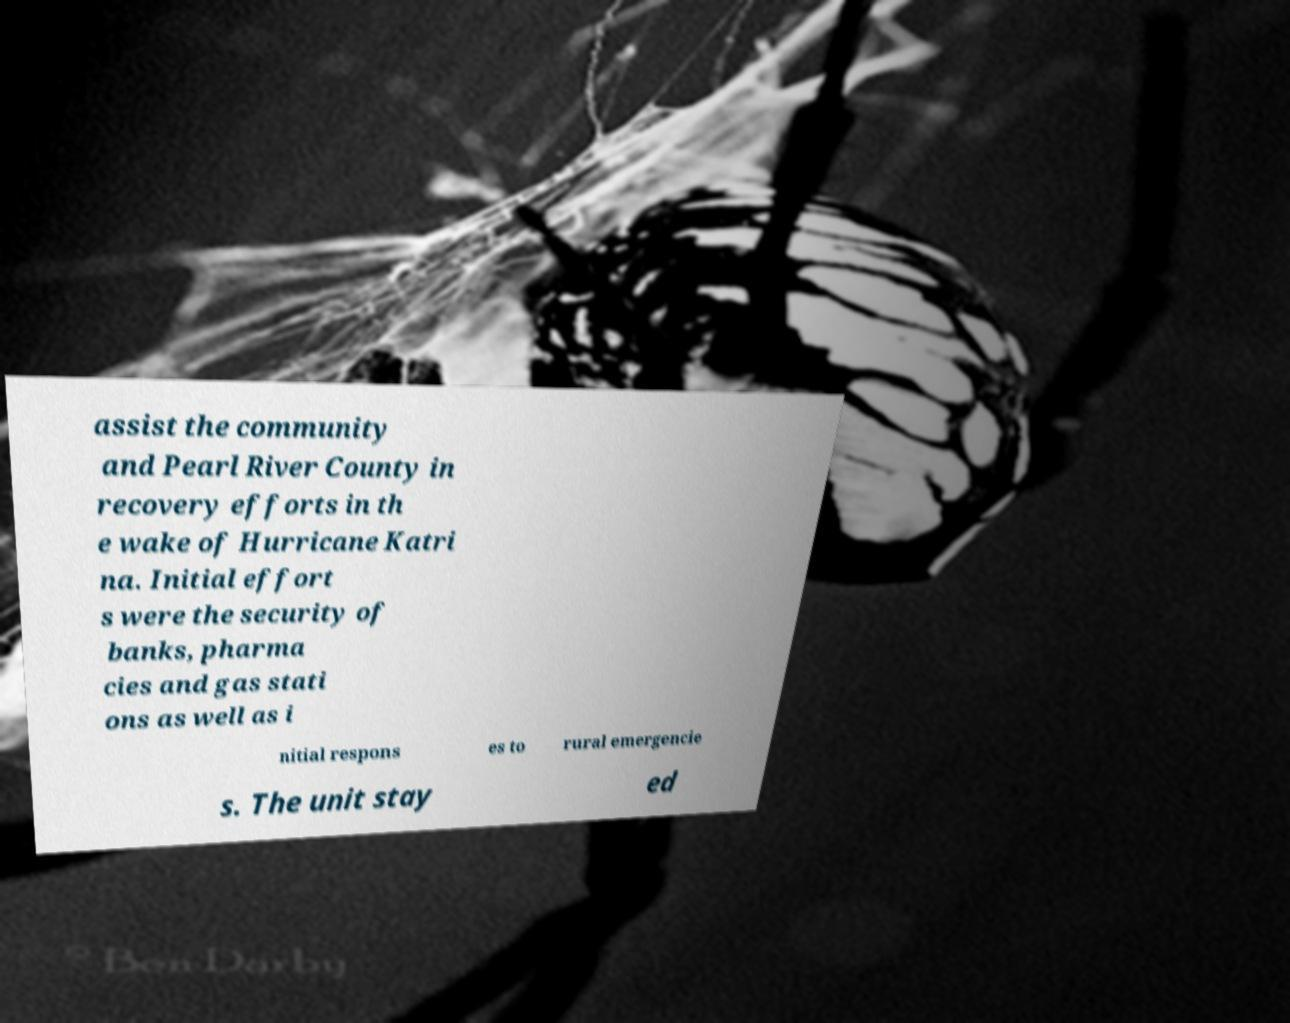Can you read and provide the text displayed in the image?This photo seems to have some interesting text. Can you extract and type it out for me? assist the community and Pearl River County in recovery efforts in th e wake of Hurricane Katri na. Initial effort s were the security of banks, pharma cies and gas stati ons as well as i nitial respons es to rural emergencie s. The unit stay ed 